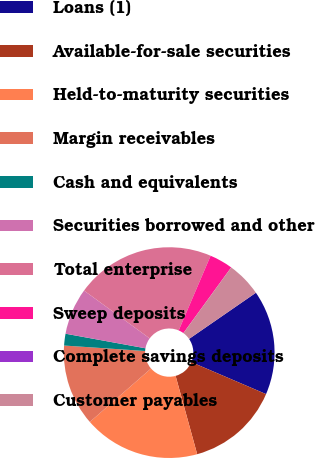<chart> <loc_0><loc_0><loc_500><loc_500><pie_chart><fcel>Loans (1)<fcel>Available-for-sale securities<fcel>Held-to-maturity securities<fcel>Margin receivables<fcel>Cash and equivalents<fcel>Securities borrowed and other<fcel>Total enterprise<fcel>Sweep deposits<fcel>Complete savings deposits<fcel>Customer payables<nl><fcel>16.06%<fcel>14.28%<fcel>17.85%<fcel>12.5%<fcel>1.8%<fcel>7.15%<fcel>21.41%<fcel>3.58%<fcel>0.01%<fcel>5.36%<nl></chart> 